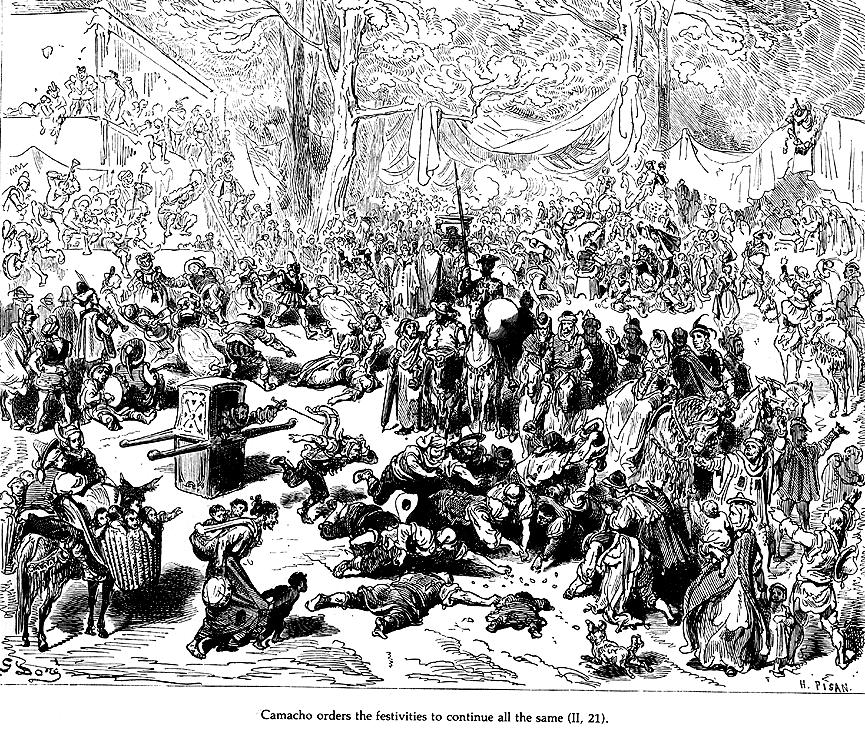Can you describe the attire of the people in the front right of the scene? In the front right of the image, several individuals are dressed in traditional early 17th-century Spanish attire, indicative of their social status and occupations. One figure is wearing a wide-brimmed hat and a decorated jerkin, which was common among the gentry of the period. Beside him, another character is adorned in a simpler, more practical tunic, likely reflecting a lower social stratum or a servant’s role. The detailed depictions of their garments, including visible lace collars and stitched patterns, offer insights into their roles and the cultural context of the era. 